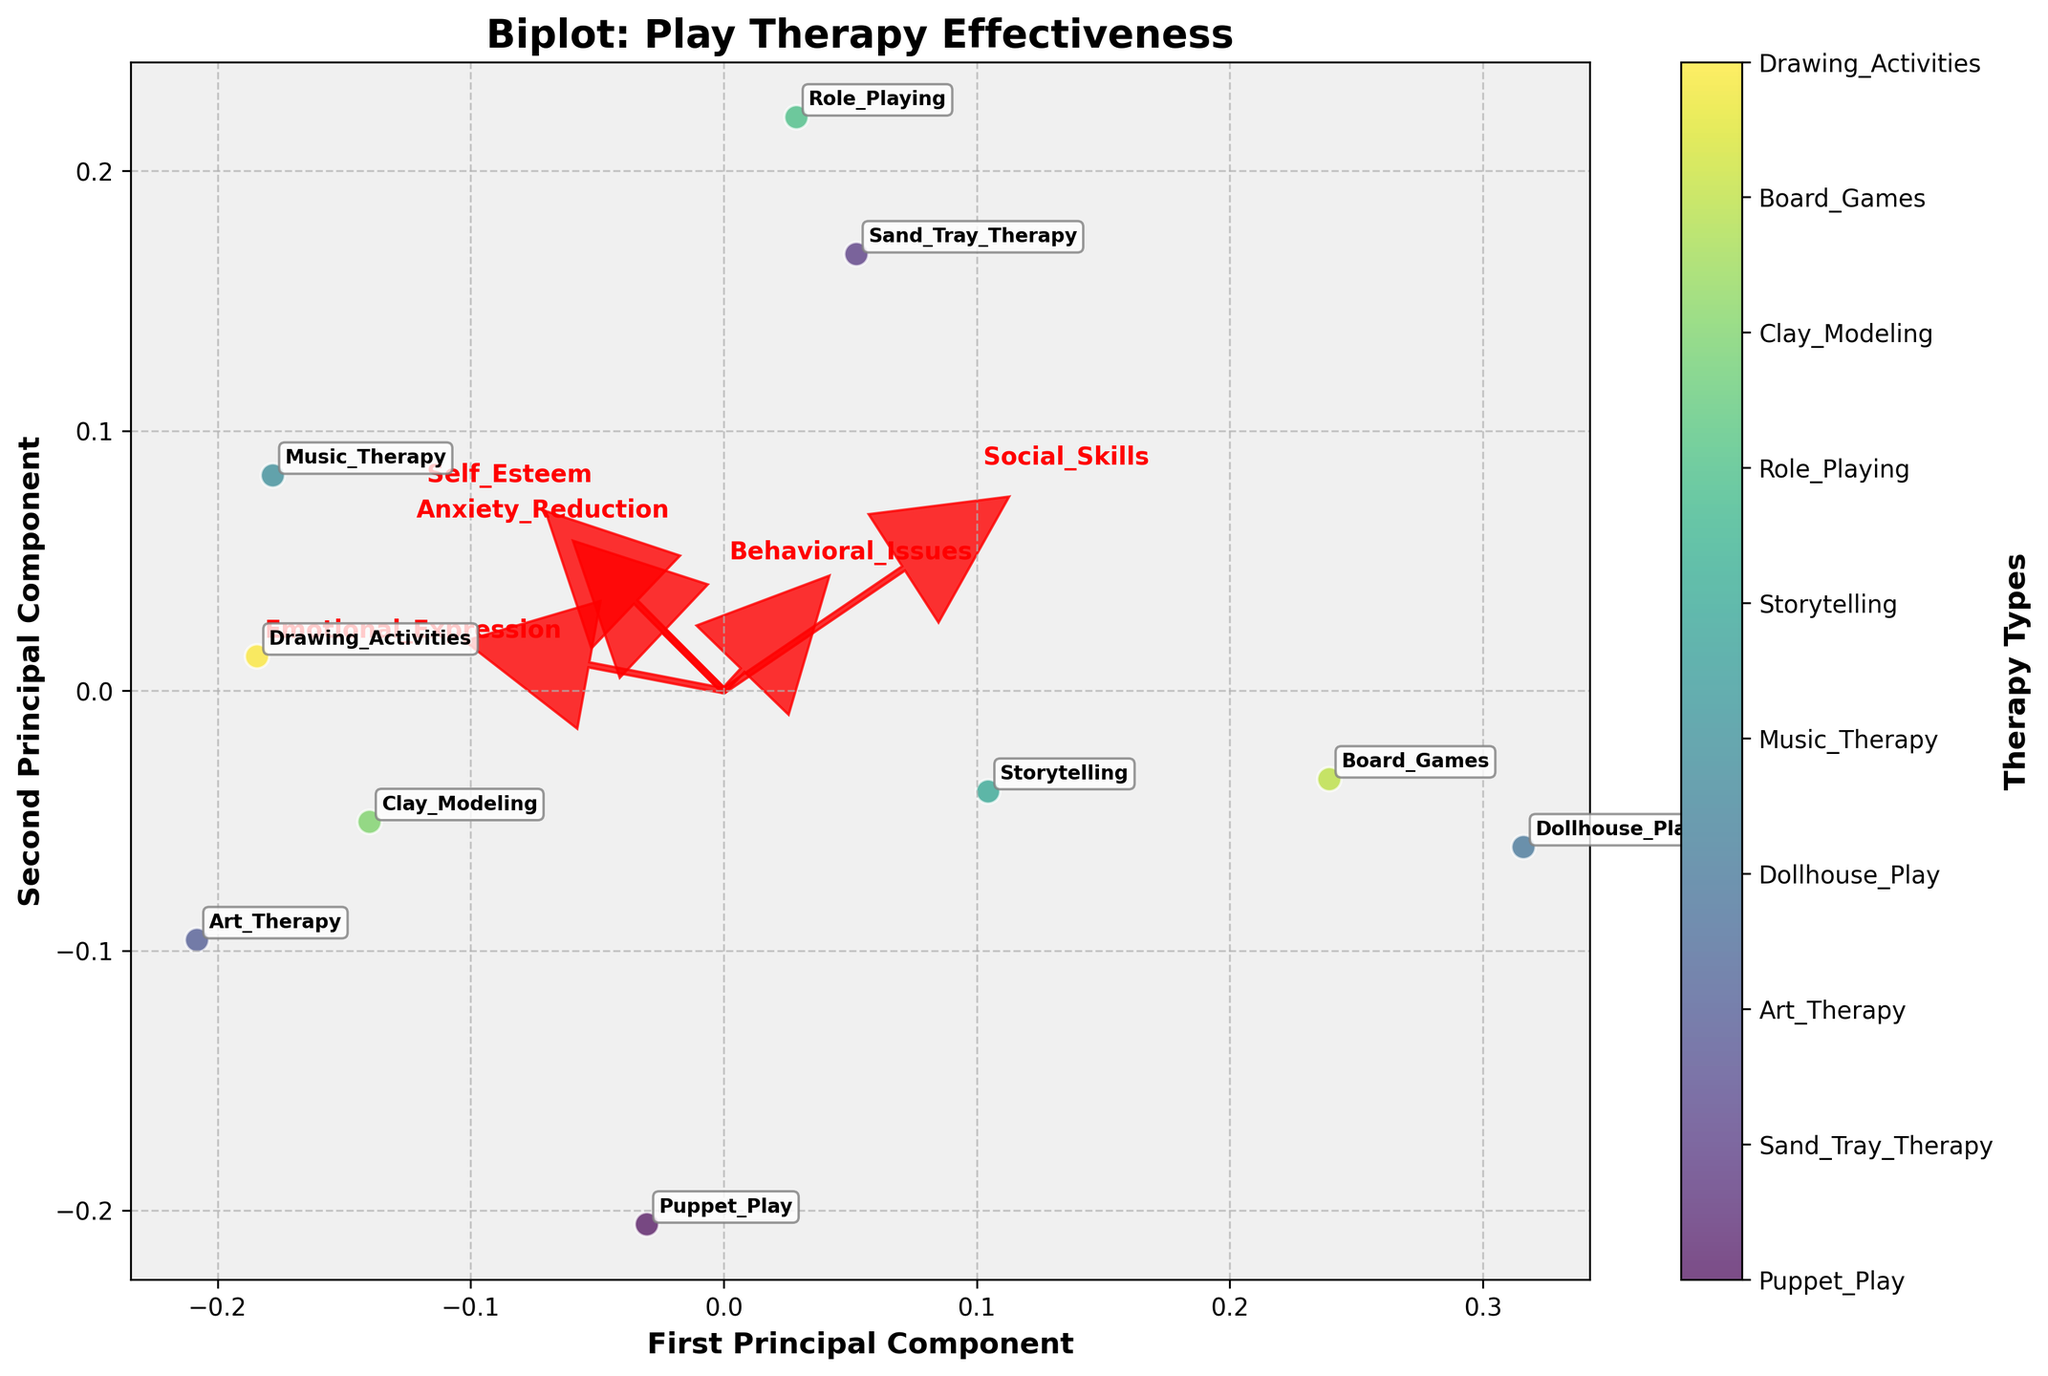What is the title of the biplot? The title is usually placed at the top of the figure, often larger in font size and bold to be easily noticeable. In this case, look at the top center of the biplot.
Answer: Biplot: Play Therapy Effectiveness How many different play therapy types are represented in the biplot? Each point in the scatter plot represents a different play therapy type, which can be counted directly. Look for the number of unique data points annotated with the therapy types' names.
Answer: 10 Which therapy type is most similar to Dollhouse Play according to their positions on the plot? To find the most similar therapy type, look for the data point (label) closest to Dollhouse Play on the scatter plot.
Answer: Board Games Which variable seems to align most closely with the First Principal Component? Variables are represented by arrows. The variable that aligns most closely with the First Principal Component will have an arrow pointing mostly along the x-axis direction.
Answer: Emotional Expression Which therapy types are highly associated with improved Social Skills? Look at the direction of the arrow for Social Skills. Therapy types in the same direction as this arrow can be considered highly associated with this variable.
Answer: Dollhouse Play, Role Playing Compare the positioning of Puppet Play and Sand Tray Therapy. Which variable differentiates them the most? To compare the two, check the relative positions of Puppet Play and Sand Tray Therapy along the direction of the arrows. Assess which variable's arrow has the greatest separation between these two points.
Answer: Anxiety Reduction Which variable has the smallest vector length, signifying the least contribution to the principal components? Vector length is represented by the length of the arrow. The variable with the shortest arrow has the least contribution.
Answer: Self Esteem Considering the plot, what overlap or relationship is observed between Storytelling and Music Therapy? Look for the proximity of the data points named Storytelling and Music Therapy. Overlapping or closely spaced points would indicate a relationship in their effectiveness indicators.
Answer: They are somewhat close, indicating similar effectiveness profiles Identify the therapy type that shows significant association with Anxiety Reduction and (approximately) equal contribution from Emotional Expression and Social Skills based on the biplot. Find the therapy type close to the direction of the Anxiety Reduction arrow and equidistant from the Emotional Expression and Social Skills arrows.
Answer: Music Therapy Which variable contributes more significantly to the second principal component than the first principal component? Variables that contribute more to the second principal component will have arrows more aligned with the y-axis direction.
Answer: Self Esteem 